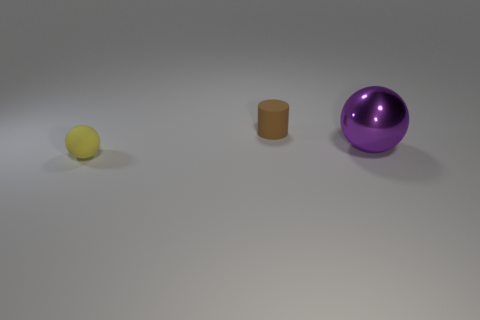Is there anything else that is the same size as the shiny ball?
Give a very brief answer. No. Is there a matte cylinder that has the same size as the yellow sphere?
Offer a terse response. Yes. Do the brown object and the thing that is on the left side of the brown cylinder have the same material?
Your answer should be compact. Yes. Is the number of small rubber spheres greater than the number of large cyan metal things?
Make the answer very short. Yes. How many cylinders are either gray objects or tiny brown rubber things?
Your answer should be compact. 1. What is the color of the metal thing?
Provide a succinct answer. Purple. There is a object in front of the large thing; is its size the same as the object to the right of the brown rubber cylinder?
Offer a very short reply. No. Is the number of large purple things less than the number of spheres?
Your response must be concise. Yes. How many big metal spheres are left of the large sphere?
Provide a succinct answer. 0. What is the purple object made of?
Give a very brief answer. Metal. 